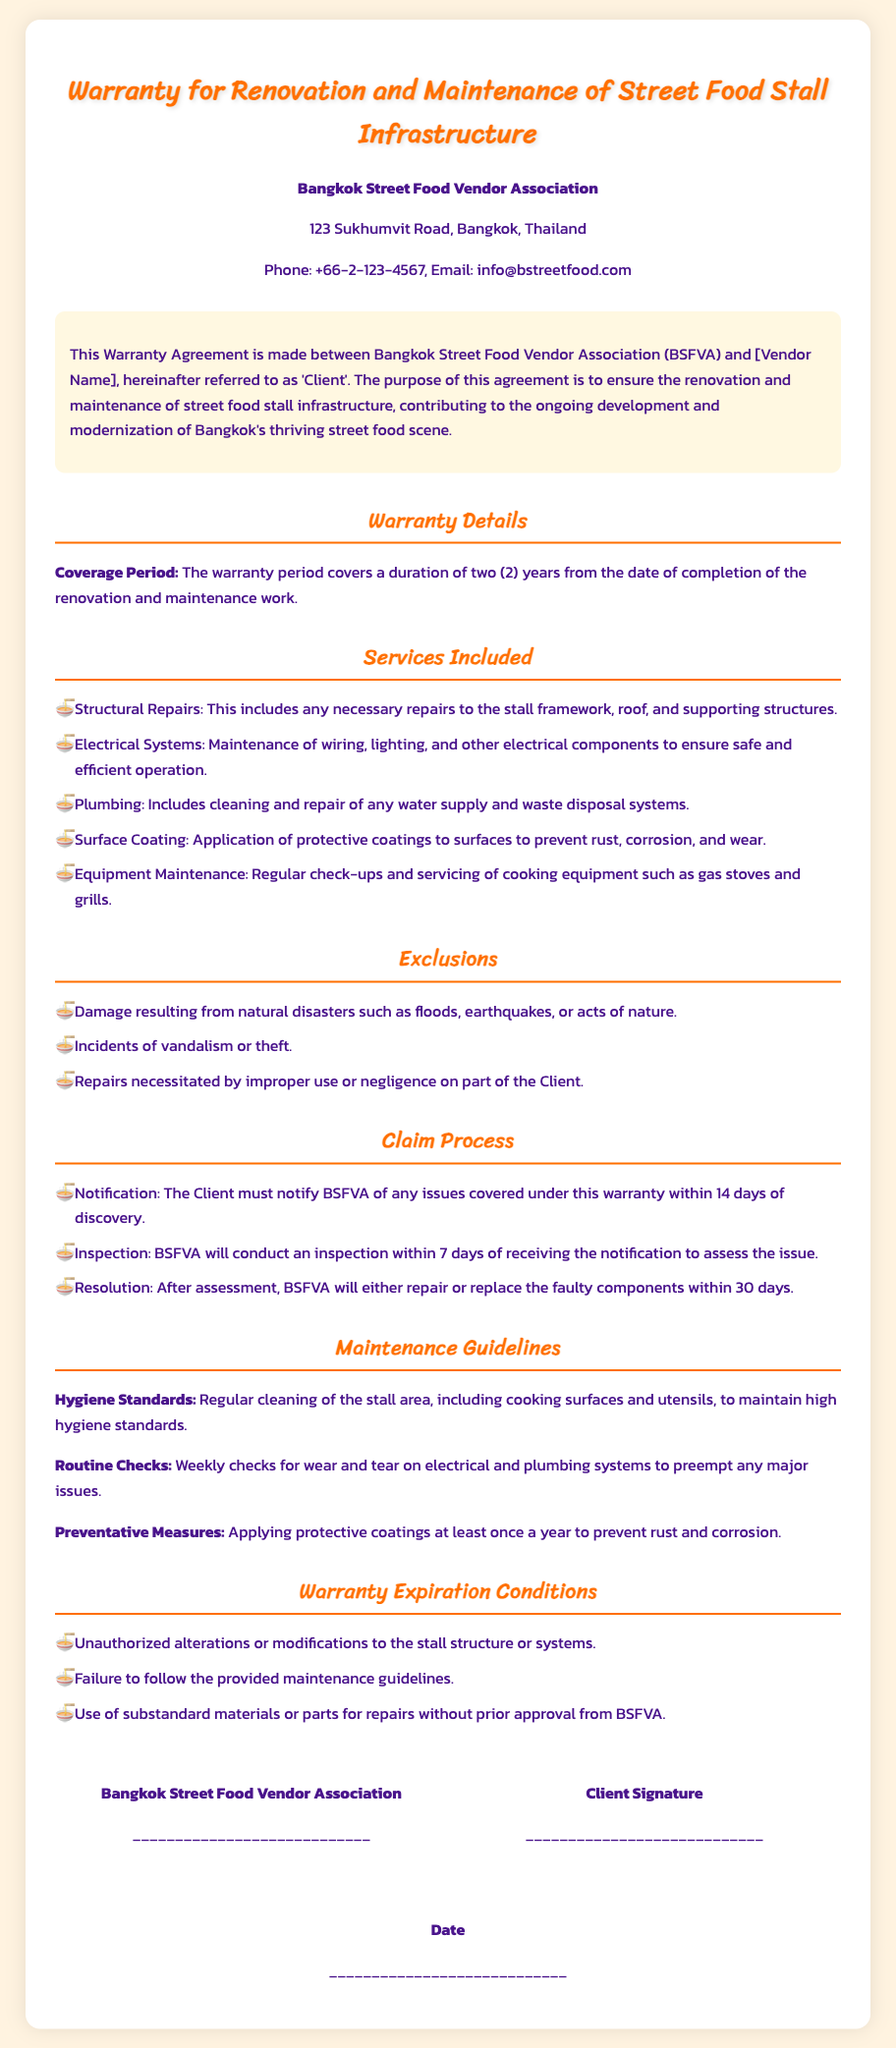What is the coverage period of the warranty? The warranty period covers a duration of two years from the date of completion of the renovation and maintenance work.
Answer: two (2) years Who is the issuer of this warranty? The issuer of the warranty is identified at the beginning of the document as the Bangkok Street Food Vendor Association.
Answer: Bangkok Street Food Vendor Association What types of repairs are included in the warranty? The document lists several services included such as Structural Repairs, Electrical Systems, Plumbing, Surface Coating, and Equipment Maintenance.
Answer: Structural Repairs, Electrical Systems, Plumbing, Surface Coating, Equipment Maintenance What is the notification period for claims? The Client must notify BSFVA of any issues covered under this warranty within a specified timeframe.
Answer: 14 days What are the exclusions listed in the warranty? Exclusions include damage from natural disasters, vandalism, and repairs due to improper use.
Answer: natural disasters, vandalism, improper use What is one of the maintenance guidelines provided? The document outlines several maintenance guidelines, one of which is about regular cleaning.
Answer: Regular cleaning of the stall area Under what condition does the warranty expire? The document specifies conditions that can lead to warranty expiration, including unauthorized alterations and failure to follow guidelines.
Answer: Unauthorized alterations How long does BSFVA have to inspect reported issues? The timeframe specified for conducting an inspection after receiving a notification is mentioned in the document.
Answer: 7 days 